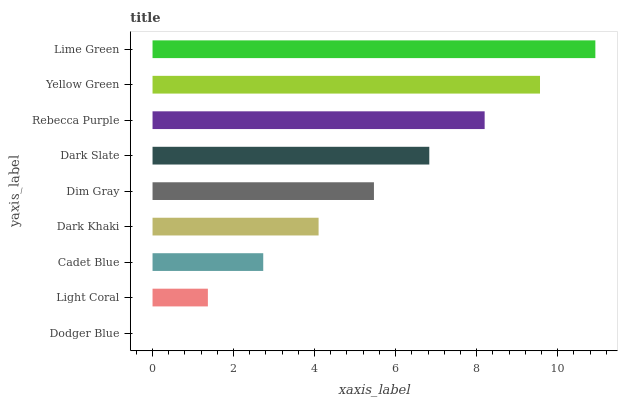Is Dodger Blue the minimum?
Answer yes or no. Yes. Is Lime Green the maximum?
Answer yes or no. Yes. Is Light Coral the minimum?
Answer yes or no. No. Is Light Coral the maximum?
Answer yes or no. No. Is Light Coral greater than Dodger Blue?
Answer yes or no. Yes. Is Dodger Blue less than Light Coral?
Answer yes or no. Yes. Is Dodger Blue greater than Light Coral?
Answer yes or no. No. Is Light Coral less than Dodger Blue?
Answer yes or no. No. Is Dim Gray the high median?
Answer yes or no. Yes. Is Dim Gray the low median?
Answer yes or no. Yes. Is Lime Green the high median?
Answer yes or no. No. Is Light Coral the low median?
Answer yes or no. No. 